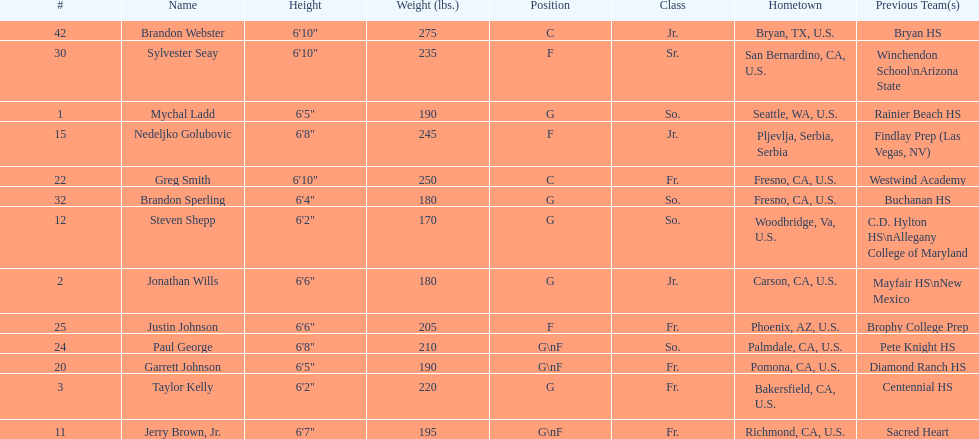What are the listed classes of the players? So., Jr., Fr., Fr., So., Jr., Fr., Fr., So., Fr., Sr., So., Jr. Which of these is not from the us? Jr. To which name does that entry correspond to? Nedeljko Golubovic. 